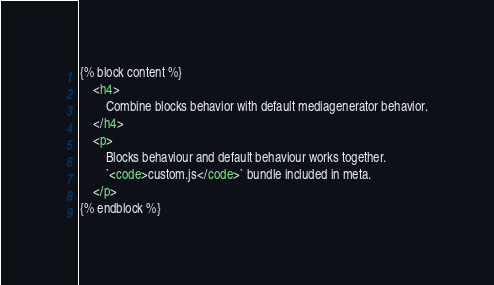<code> <loc_0><loc_0><loc_500><loc_500><_HTML_>{% block content %}
    <h4>
        Combine blocks behavior with default mediagenerator behavior.
    </h4>
    <p>
        Blocks behaviour and default behaviour works together. 
        `<code>custom.js</code>` bundle included in meta.
    </p>
{% endblock %}
</code> 